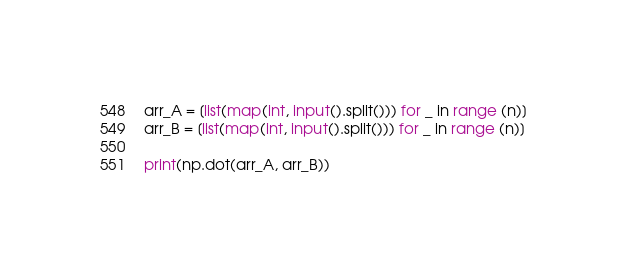<code> <loc_0><loc_0><loc_500><loc_500><_Python_>
arr_A = [list(map(int, input().split())) for _ in range (n)]
arr_B = [list(map(int, input().split())) for _ in range (n)]

print(np.dot(arr_A, arr_B))</code> 